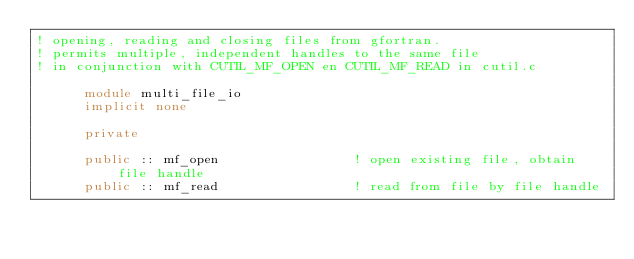Convert code to text. <code><loc_0><loc_0><loc_500><loc_500><_FORTRAN_>! opening, reading and closing files from gfortran.
! permits multiple, independent handles to the same file 
! in conjunction with CUTIL_MF_OPEN en CUTIL_MF_READ in cutil.c

      module multi_file_io
      implicit none 

      private
        
      public :: mf_open                 ! open existing file, obtain file handle  
      public :: mf_read                 ! read from file by file handle </code> 